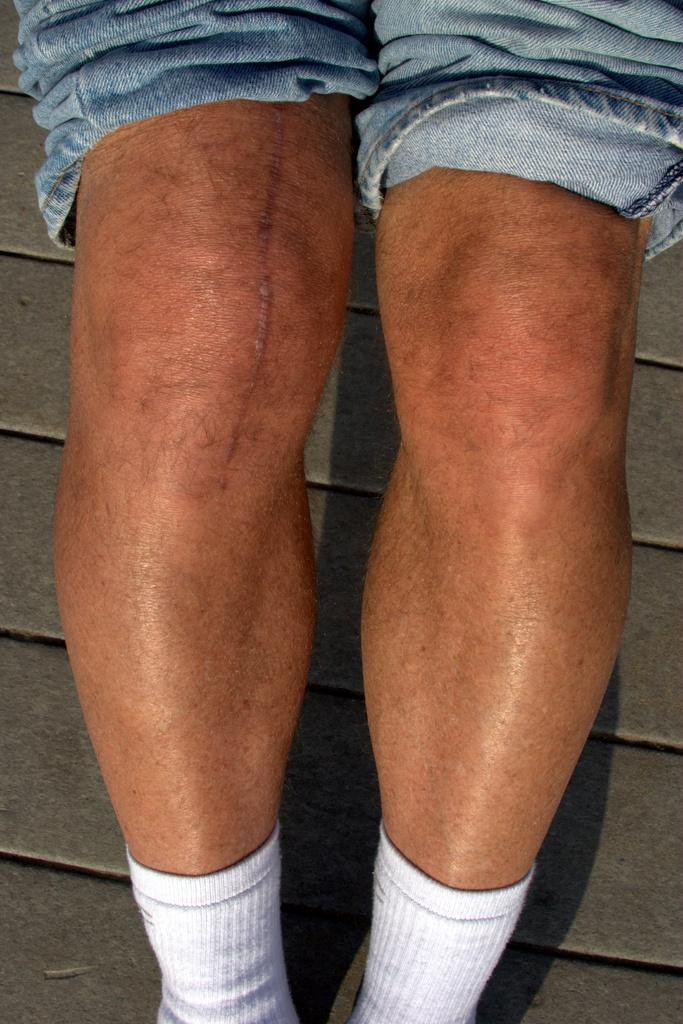What can be seen in the image related to a person's legs? There are legs of a person visible in the image, and the person has rolled up their jeans. What type of footwear is the person wearing? The person is wearing socks in the image. Is there any noticeable feature on the person's legs? Yes, there is a scar on the right leg of the person. What can be seen in the background of the image? There are stairs in the background of the image. What type of lipstick is the person wearing in the image? There is no lipstick or any indication of lip color in the image; the focus is on the person's legs and attire. 